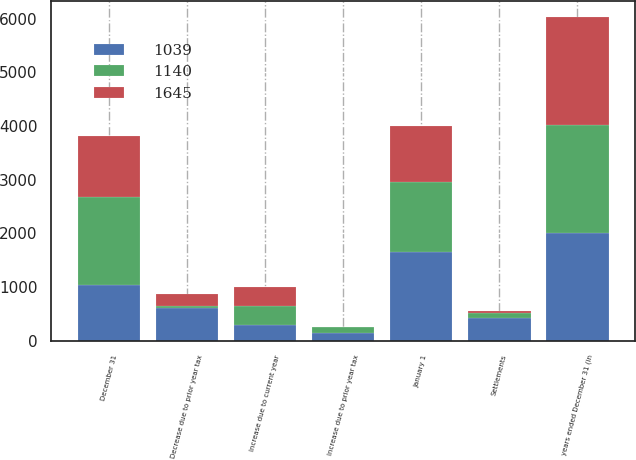<chart> <loc_0><loc_0><loc_500><loc_500><stacked_bar_chart><ecel><fcel>years ended December 31 (in<fcel>January 1<fcel>Increase due to current year<fcel>Increase due to prior year tax<fcel>Decrease due to prior year tax<fcel>Settlements<fcel>December 31<nl><fcel>1645<fcel>2012<fcel>1039<fcel>370<fcel>1<fcel>220<fcel>50<fcel>1140<nl><fcel>1039<fcel>2011<fcel>1645<fcel>294<fcel>149<fcel>604<fcel>430<fcel>1039<nl><fcel>1140<fcel>2010<fcel>1319<fcel>346<fcel>110<fcel>48<fcel>82<fcel>1645<nl></chart> 